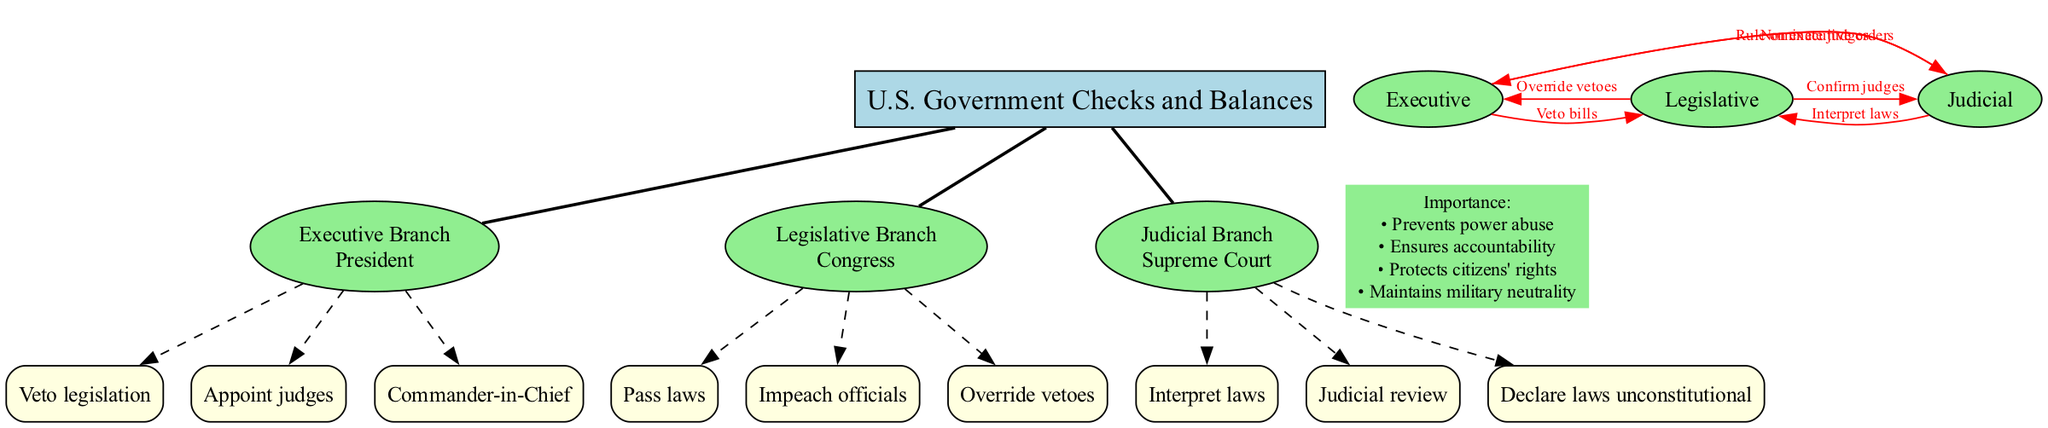What is the central concept of this diagram? The central concept node clearly states that the focus of the diagram is on the "U.S. Government Checks and Balances," which is presented at the top of the diagram.
Answer: U.S. Government Checks and Balances Which branch is led by the President? The diagram indicates that the Executive Branch is associated with the key figure of the President as shown in the node's content.
Answer: Executive Branch How many powers does the Legislative Branch have listed? By counting the dashed connections stemming from the Legislative Branch node, we see there are three powers related to it, indicating its scope of authority.
Answer: 3 What action does the Legislative Branch take towards the Executive Branch? The diagram shows that one of the checks from the Legislative Branch to the Executive is to "Override vetoes," which is indicated by the directed edge connecting them labeled with this action.
Answer: Override vetoes What is the role of the Supreme Court in the checks and balances system? The diagram indicates that the Supreme Court, under the Judicial Branch, performs the function of "Interpret laws," as described in the connections it has within the diagram.
Answer: Interpret laws How many total checks are represented in the diagram? By counting the edges labeled as checks in the diagram, we find there are six distinct checks that illustrate the interactions between the three branches.
Answer: 6 What is one importance of the checks and balances system listed in the diagram? The diagram enumerates several key points, and one of them states that it "Prevents power abuse," highlighting a crucial reason for the existence of checks and balances in government.
Answer: Prevents power abuse Which branch can nominate judges? The diagram indicates that the Executive Branch has the power to "Nominate judges," which establishes its influence over the Judicial Branch through this specific action.
Answer: Executive Branch What type of action is shown from the Judicial Branch to the Legislative Branch? The diagram shows the action from the Judicial Branch to the Legislative Branch as "Interpret laws," reflecting its role in providing clarity on the legislation passed by Congress.
Answer: Interpret laws 